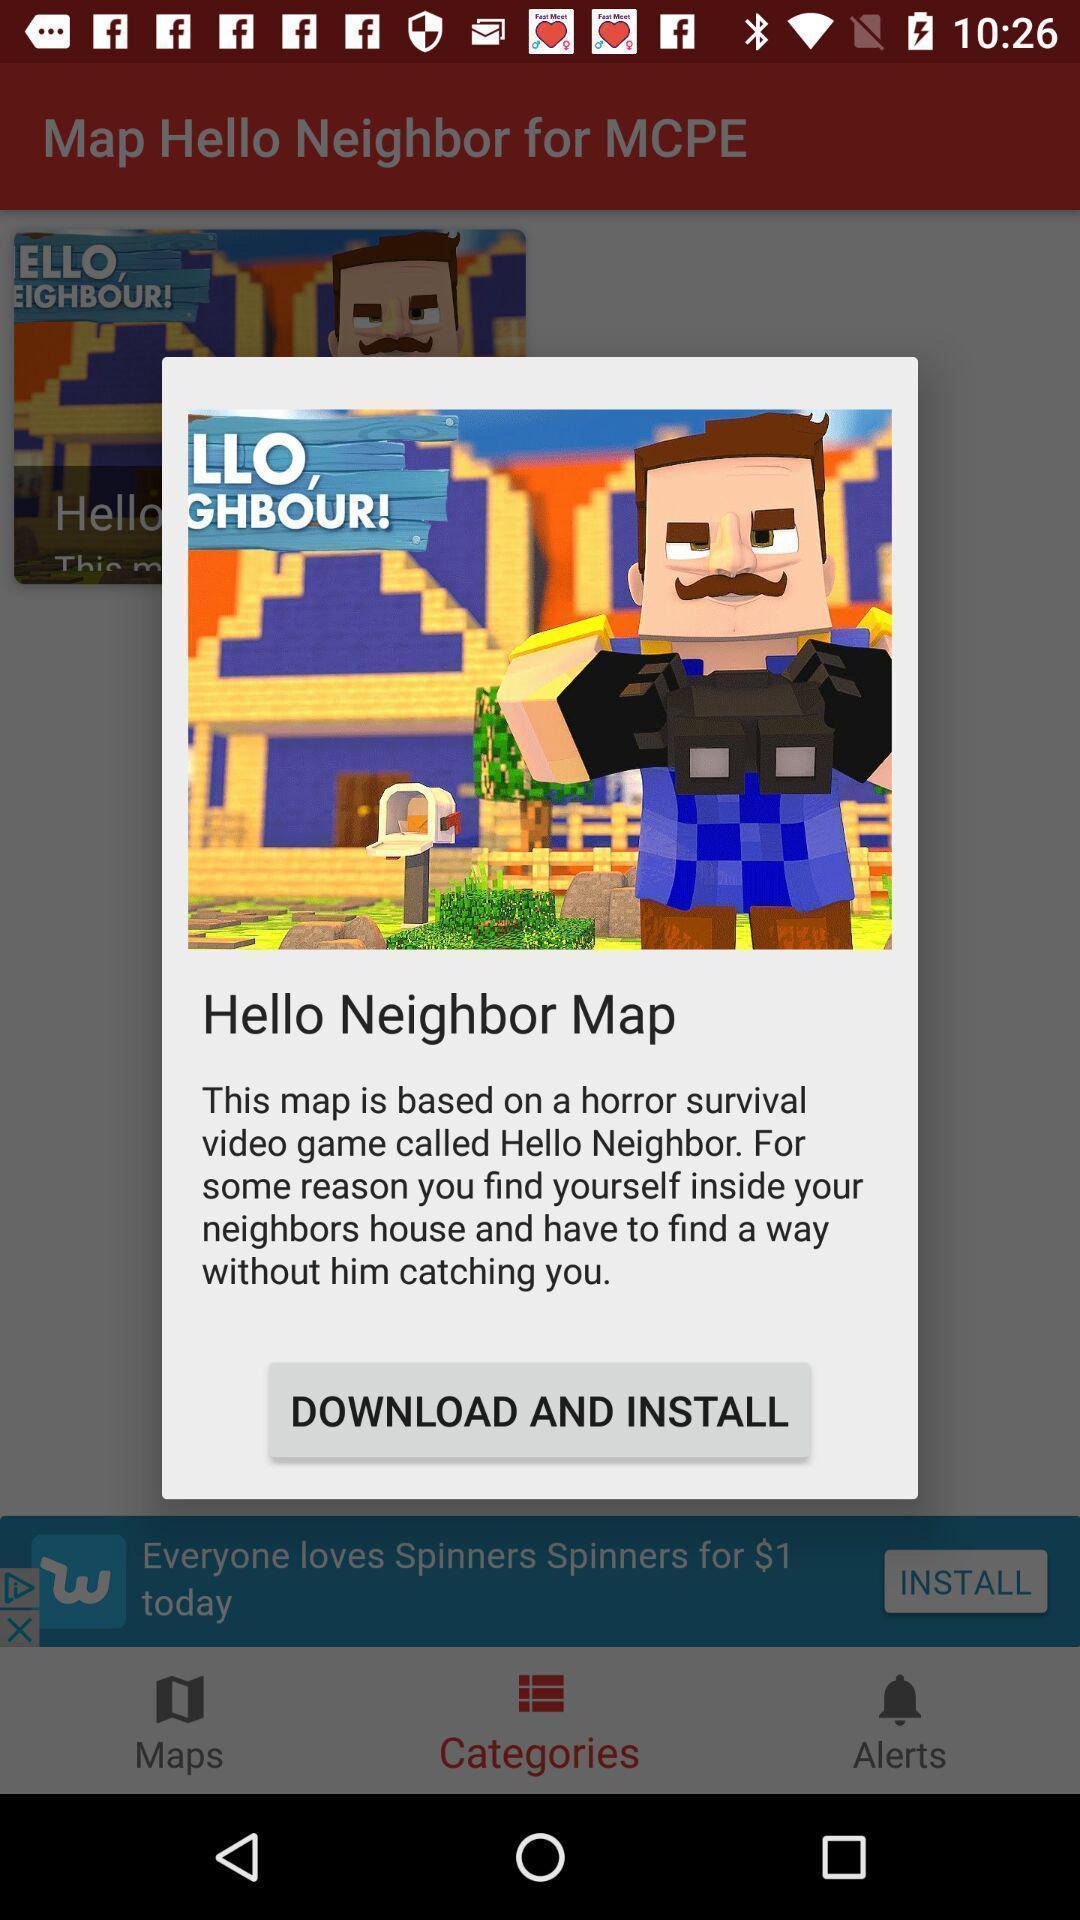Explain the elements present in this screenshot. Pop-up showing a notification to install app. 